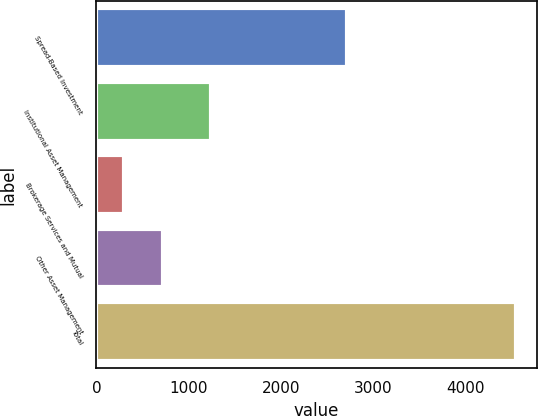Convert chart to OTSL. <chart><loc_0><loc_0><loc_500><loc_500><bar_chart><fcel>Spread-Based Investment<fcel>Institutional Asset Management<fcel>Brokerage Services and Mutual<fcel>Other Asset Management<fcel>Total<nl><fcel>2713<fcel>1240<fcel>293<fcel>718<fcel>4543<nl></chart> 